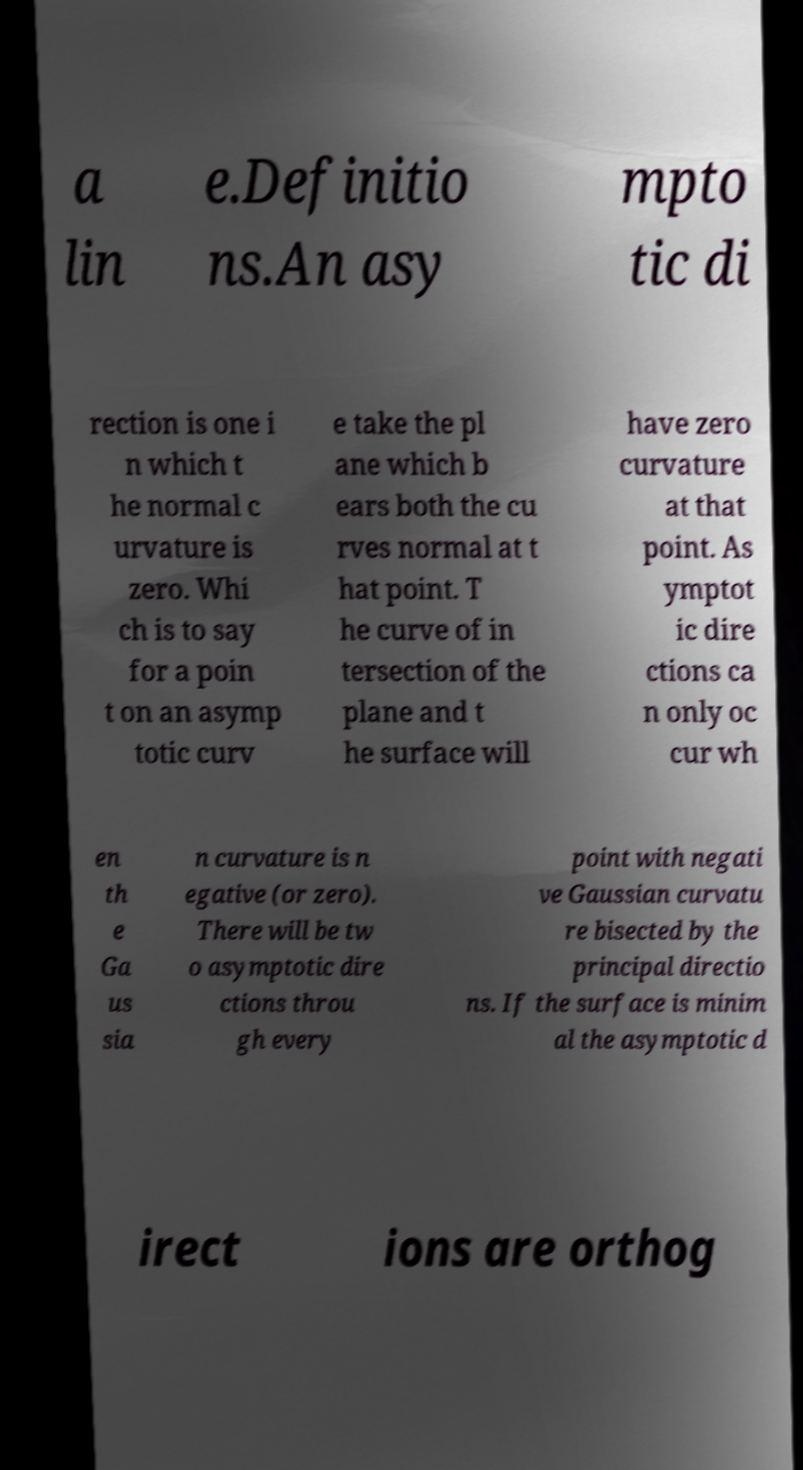What messages or text are displayed in this image? I need them in a readable, typed format. a lin e.Definitio ns.An asy mpto tic di rection is one i n which t he normal c urvature is zero. Whi ch is to say for a poin t on an asymp totic curv e take the pl ane which b ears both the cu rves normal at t hat point. T he curve of in tersection of the plane and t he surface will have zero curvature at that point. As ymptot ic dire ctions ca n only oc cur wh en th e Ga us sia n curvature is n egative (or zero). There will be tw o asymptotic dire ctions throu gh every point with negati ve Gaussian curvatu re bisected by the principal directio ns. If the surface is minim al the asymptotic d irect ions are orthog 